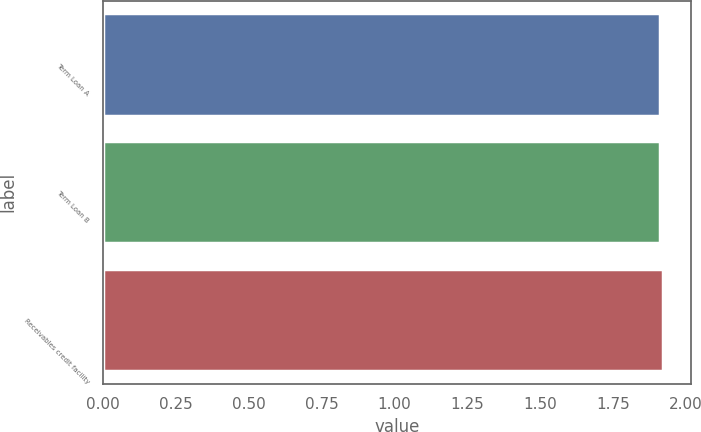<chart> <loc_0><loc_0><loc_500><loc_500><bar_chart><fcel>Term Loan A<fcel>Term Loan B<fcel>Receivables credit facility<nl><fcel>1.91<fcel>1.91<fcel>1.92<nl></chart> 